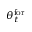<formula> <loc_0><loc_0><loc_500><loc_500>\theta _ { t } ^ { f o r }</formula> 